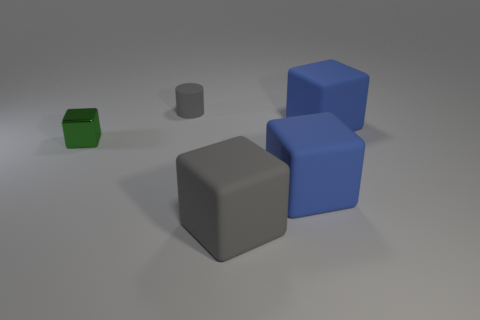How many objects are there in total, and can you describe their colors? There are five objects in total in the image. Two of them are blue cubes, one is a gray cube, one is a green cube, and one is a gray cylinder. 